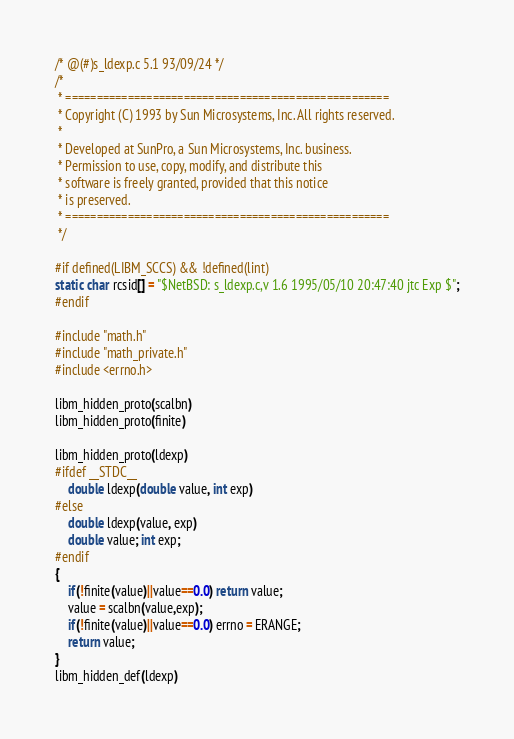<code> <loc_0><loc_0><loc_500><loc_500><_C_>/* @(#)s_ldexp.c 5.1 93/09/24 */
/*
 * ====================================================
 * Copyright (C) 1993 by Sun Microsystems, Inc. All rights reserved.
 *
 * Developed at SunPro, a Sun Microsystems, Inc. business.
 * Permission to use, copy, modify, and distribute this
 * software is freely granted, provided that this notice
 * is preserved.
 * ====================================================
 */

#if defined(LIBM_SCCS) && !defined(lint)
static char rcsid[] = "$NetBSD: s_ldexp.c,v 1.6 1995/05/10 20:47:40 jtc Exp $";
#endif

#include "math.h"
#include "math_private.h"
#include <errno.h>

libm_hidden_proto(scalbn)
libm_hidden_proto(finite)

libm_hidden_proto(ldexp)
#ifdef __STDC__
	double ldexp(double value, int exp)
#else
	double ldexp(value, exp)
	double value; int exp;
#endif
{
	if(!finite(value)||value==0.0) return value;
	value = scalbn(value,exp);
	if(!finite(value)||value==0.0) errno = ERANGE;
	return value;
}
libm_hidden_def(ldexp)
</code> 